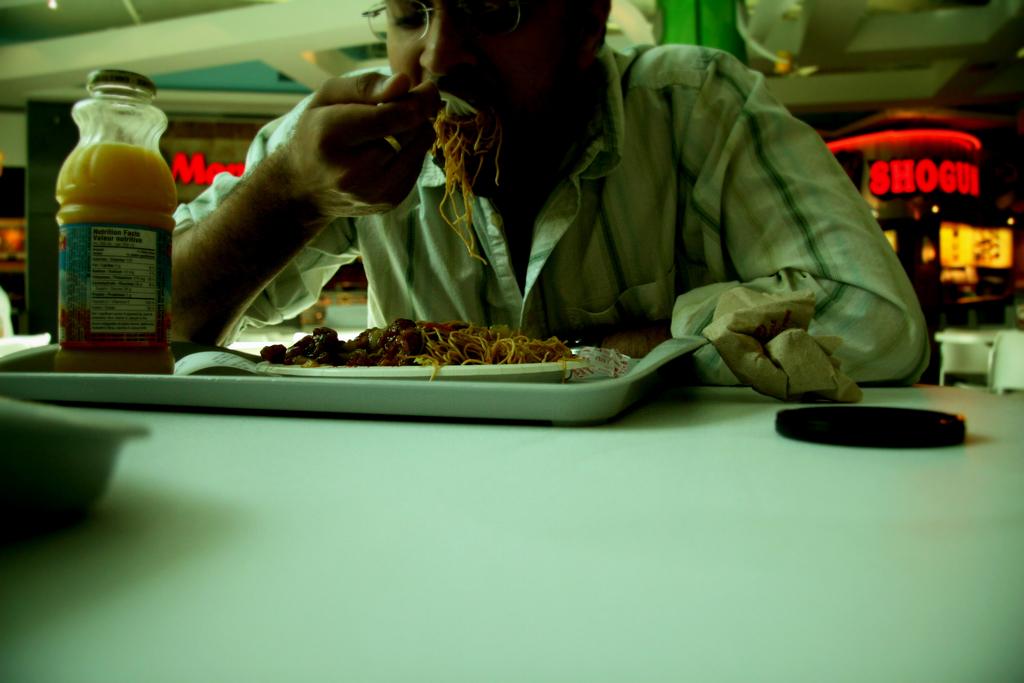What is in red on the right side?
Give a very brief answer. Shogun. 